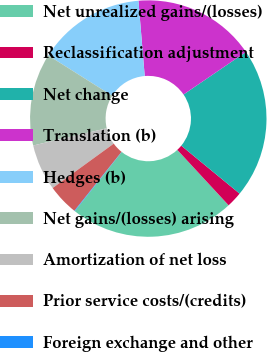Convert chart. <chart><loc_0><loc_0><loc_500><loc_500><pie_chart><fcel>Net unrealized gains/(losses)<fcel>Reclassification adjustment<fcel>Net change<fcel>Translation (b)<fcel>Hedges (b)<fcel>Net gains/(losses) arising<fcel>Amortization of net loss<fcel>Prior service costs/(credits)<fcel>Foreign exchange and other<nl><fcel>22.57%<fcel>2.16%<fcel>20.48%<fcel>16.8%<fcel>14.71%<fcel>12.62%<fcel>6.34%<fcel>4.25%<fcel>0.07%<nl></chart> 